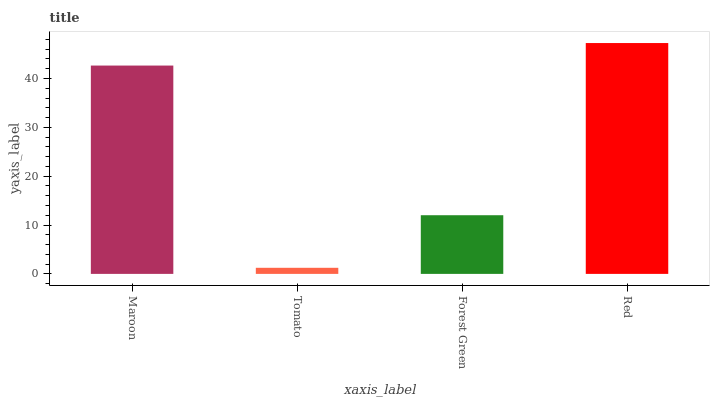Is Tomato the minimum?
Answer yes or no. Yes. Is Red the maximum?
Answer yes or no. Yes. Is Forest Green the minimum?
Answer yes or no. No. Is Forest Green the maximum?
Answer yes or no. No. Is Forest Green greater than Tomato?
Answer yes or no. Yes. Is Tomato less than Forest Green?
Answer yes or no. Yes. Is Tomato greater than Forest Green?
Answer yes or no. No. Is Forest Green less than Tomato?
Answer yes or no. No. Is Maroon the high median?
Answer yes or no. Yes. Is Forest Green the low median?
Answer yes or no. Yes. Is Forest Green the high median?
Answer yes or no. No. Is Red the low median?
Answer yes or no. No. 